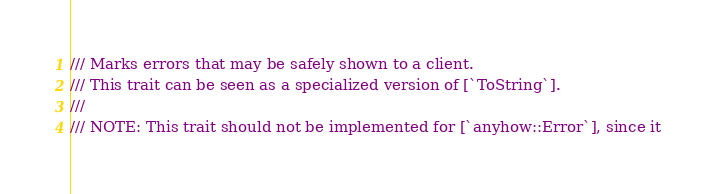<code> <loc_0><loc_0><loc_500><loc_500><_Rust_>/// Marks errors that may be safely shown to a client.
/// This trait can be seen as a specialized version of [`ToString`].
///
/// NOTE: This trait should not be implemented for [`anyhow::Error`], since it</code> 